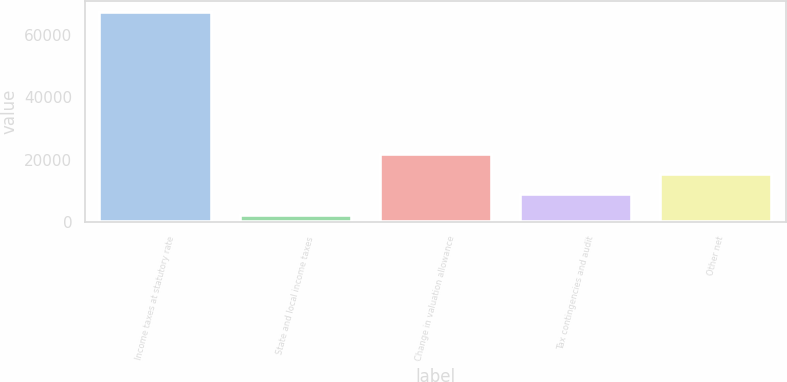<chart> <loc_0><loc_0><loc_500><loc_500><bar_chart><fcel>Income taxes at statutory rate<fcel>State and local income taxes<fcel>Change in valuation allowance<fcel>Tax contingencies and audit<fcel>Other net<nl><fcel>67427<fcel>2358<fcel>21878.7<fcel>8864.9<fcel>15371.8<nl></chart> 